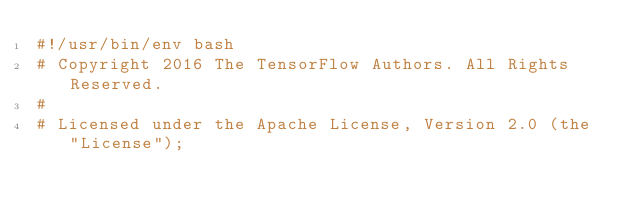<code> <loc_0><loc_0><loc_500><loc_500><_Bash_>#!/usr/bin/env bash
# Copyright 2016 The TensorFlow Authors. All Rights Reserved.
#
# Licensed under the Apache License, Version 2.0 (the "License");</code> 